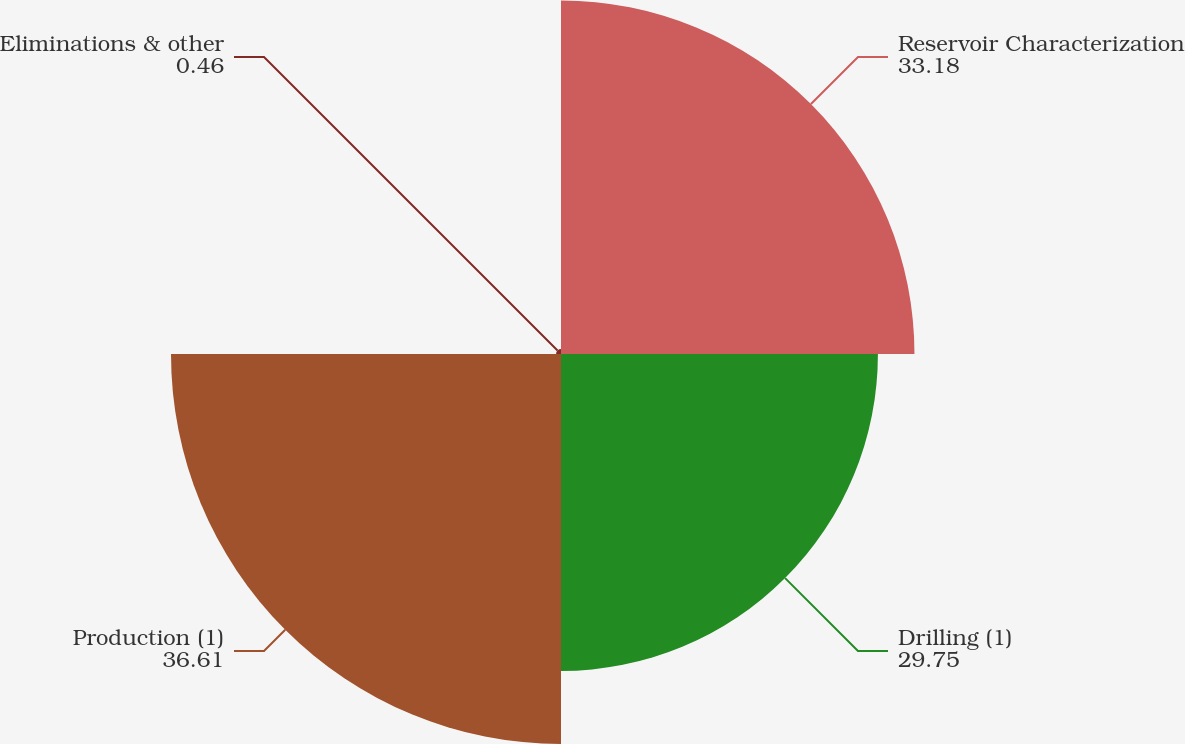<chart> <loc_0><loc_0><loc_500><loc_500><pie_chart><fcel>Reservoir Characterization<fcel>Drilling (1)<fcel>Production (1)<fcel>Eliminations & other<nl><fcel>33.18%<fcel>29.75%<fcel>36.61%<fcel>0.46%<nl></chart> 